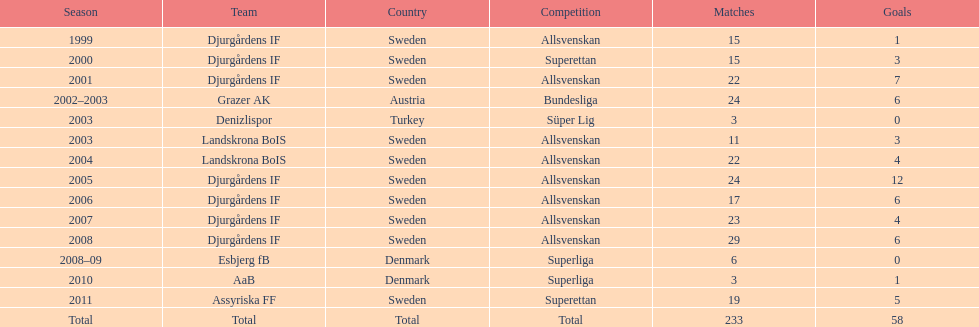What team has the most goals? Djurgårdens IF. 